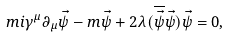Convert formula to latex. <formula><loc_0><loc_0><loc_500><loc_500>\ m i \gamma ^ { \mu } \partial _ { \mu } \vec { \psi } - m \vec { \psi } + 2 \lambda ( \overline { \vec { \psi } } \vec { \psi } ) \vec { \psi } = 0 ,</formula> 